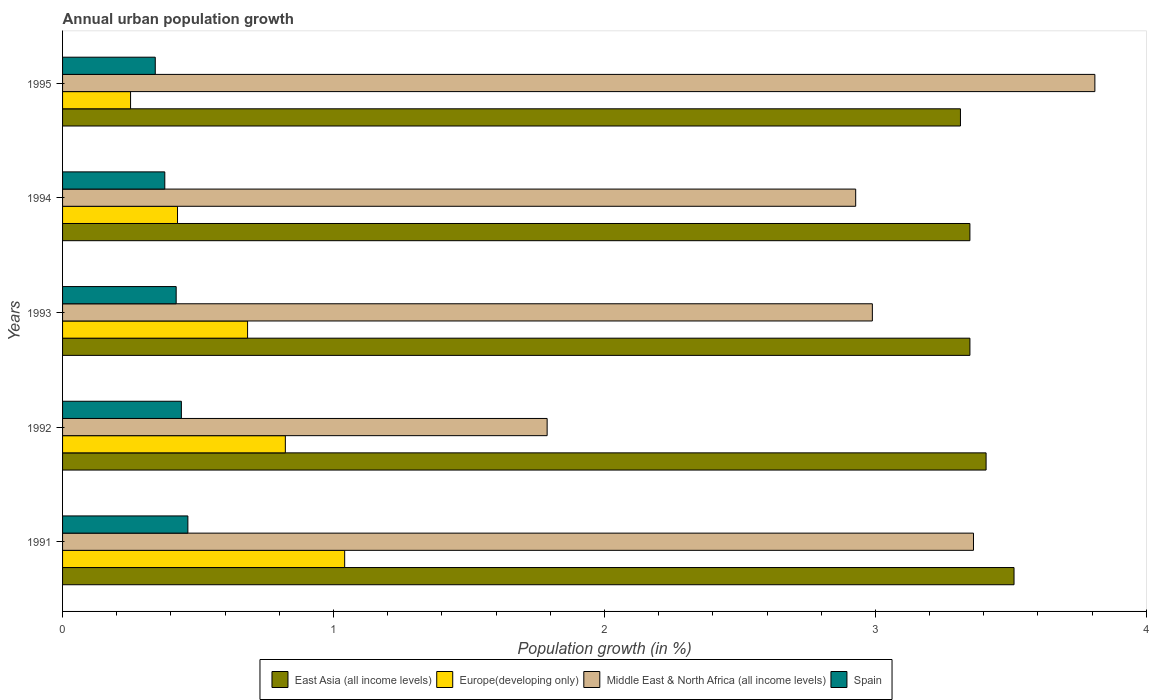How many different coloured bars are there?
Provide a succinct answer. 4. Are the number of bars per tick equal to the number of legend labels?
Provide a short and direct response. Yes. Are the number of bars on each tick of the Y-axis equal?
Make the answer very short. Yes. How many bars are there on the 1st tick from the top?
Give a very brief answer. 4. What is the label of the 1st group of bars from the top?
Give a very brief answer. 1995. In how many cases, is the number of bars for a given year not equal to the number of legend labels?
Keep it short and to the point. 0. What is the percentage of urban population growth in Europe(developing only) in 1995?
Keep it short and to the point. 0.25. Across all years, what is the maximum percentage of urban population growth in Spain?
Make the answer very short. 0.46. Across all years, what is the minimum percentage of urban population growth in Middle East & North Africa (all income levels)?
Make the answer very short. 1.79. What is the total percentage of urban population growth in Middle East & North Africa (all income levels) in the graph?
Keep it short and to the point. 14.88. What is the difference between the percentage of urban population growth in Europe(developing only) in 1993 and that in 1995?
Provide a short and direct response. 0.43. What is the difference between the percentage of urban population growth in Middle East & North Africa (all income levels) in 1993 and the percentage of urban population growth in East Asia (all income levels) in 1995?
Offer a terse response. -0.33. What is the average percentage of urban population growth in Spain per year?
Your response must be concise. 0.41. In the year 1991, what is the difference between the percentage of urban population growth in Spain and percentage of urban population growth in Europe(developing only)?
Make the answer very short. -0.58. In how many years, is the percentage of urban population growth in Spain greater than 2.6 %?
Provide a succinct answer. 0. What is the ratio of the percentage of urban population growth in Middle East & North Africa (all income levels) in 1993 to that in 1994?
Offer a very short reply. 1.02. Is the difference between the percentage of urban population growth in Spain in 1991 and 1994 greater than the difference between the percentage of urban population growth in Europe(developing only) in 1991 and 1994?
Offer a terse response. No. What is the difference between the highest and the second highest percentage of urban population growth in Spain?
Your response must be concise. 0.02. What is the difference between the highest and the lowest percentage of urban population growth in Europe(developing only)?
Give a very brief answer. 0.79. Is the sum of the percentage of urban population growth in Middle East & North Africa (all income levels) in 1994 and 1995 greater than the maximum percentage of urban population growth in Spain across all years?
Give a very brief answer. Yes. Is it the case that in every year, the sum of the percentage of urban population growth in Europe(developing only) and percentage of urban population growth in Middle East & North Africa (all income levels) is greater than the sum of percentage of urban population growth in East Asia (all income levels) and percentage of urban population growth in Spain?
Provide a succinct answer. Yes. What does the 1st bar from the bottom in 1992 represents?
Offer a terse response. East Asia (all income levels). Is it the case that in every year, the sum of the percentage of urban population growth in East Asia (all income levels) and percentage of urban population growth in Europe(developing only) is greater than the percentage of urban population growth in Middle East & North Africa (all income levels)?
Keep it short and to the point. No. Are all the bars in the graph horizontal?
Your answer should be very brief. Yes. How many years are there in the graph?
Provide a succinct answer. 5. What is the difference between two consecutive major ticks on the X-axis?
Ensure brevity in your answer.  1. Are the values on the major ticks of X-axis written in scientific E-notation?
Your response must be concise. No. Does the graph contain grids?
Your answer should be very brief. No. Where does the legend appear in the graph?
Your answer should be very brief. Bottom center. What is the title of the graph?
Your response must be concise. Annual urban population growth. Does "Panama" appear as one of the legend labels in the graph?
Your answer should be compact. No. What is the label or title of the X-axis?
Give a very brief answer. Population growth (in %). What is the label or title of the Y-axis?
Your response must be concise. Years. What is the Population growth (in %) of East Asia (all income levels) in 1991?
Your answer should be compact. 3.51. What is the Population growth (in %) in Europe(developing only) in 1991?
Your response must be concise. 1.04. What is the Population growth (in %) of Middle East & North Africa (all income levels) in 1991?
Your answer should be very brief. 3.36. What is the Population growth (in %) in Spain in 1991?
Keep it short and to the point. 0.46. What is the Population growth (in %) in East Asia (all income levels) in 1992?
Provide a short and direct response. 3.41. What is the Population growth (in %) in Europe(developing only) in 1992?
Offer a terse response. 0.82. What is the Population growth (in %) in Middle East & North Africa (all income levels) in 1992?
Provide a short and direct response. 1.79. What is the Population growth (in %) in Spain in 1992?
Make the answer very short. 0.44. What is the Population growth (in %) in East Asia (all income levels) in 1993?
Provide a succinct answer. 3.35. What is the Population growth (in %) in Europe(developing only) in 1993?
Give a very brief answer. 0.68. What is the Population growth (in %) of Middle East & North Africa (all income levels) in 1993?
Ensure brevity in your answer.  2.99. What is the Population growth (in %) in Spain in 1993?
Provide a short and direct response. 0.42. What is the Population growth (in %) of East Asia (all income levels) in 1994?
Offer a very short reply. 3.35. What is the Population growth (in %) in Europe(developing only) in 1994?
Offer a terse response. 0.42. What is the Population growth (in %) of Middle East & North Africa (all income levels) in 1994?
Ensure brevity in your answer.  2.93. What is the Population growth (in %) in Spain in 1994?
Your answer should be compact. 0.38. What is the Population growth (in %) of East Asia (all income levels) in 1995?
Your response must be concise. 3.31. What is the Population growth (in %) of Europe(developing only) in 1995?
Keep it short and to the point. 0.25. What is the Population growth (in %) in Middle East & North Africa (all income levels) in 1995?
Keep it short and to the point. 3.81. What is the Population growth (in %) of Spain in 1995?
Your answer should be very brief. 0.34. Across all years, what is the maximum Population growth (in %) in East Asia (all income levels)?
Give a very brief answer. 3.51. Across all years, what is the maximum Population growth (in %) in Europe(developing only)?
Provide a short and direct response. 1.04. Across all years, what is the maximum Population growth (in %) in Middle East & North Africa (all income levels)?
Provide a short and direct response. 3.81. Across all years, what is the maximum Population growth (in %) of Spain?
Provide a short and direct response. 0.46. Across all years, what is the minimum Population growth (in %) of East Asia (all income levels)?
Offer a very short reply. 3.31. Across all years, what is the minimum Population growth (in %) of Europe(developing only)?
Provide a short and direct response. 0.25. Across all years, what is the minimum Population growth (in %) in Middle East & North Africa (all income levels)?
Provide a short and direct response. 1.79. Across all years, what is the minimum Population growth (in %) of Spain?
Offer a very short reply. 0.34. What is the total Population growth (in %) of East Asia (all income levels) in the graph?
Provide a succinct answer. 16.93. What is the total Population growth (in %) of Europe(developing only) in the graph?
Make the answer very short. 3.22. What is the total Population growth (in %) of Middle East & North Africa (all income levels) in the graph?
Make the answer very short. 14.88. What is the total Population growth (in %) of Spain in the graph?
Make the answer very short. 2.04. What is the difference between the Population growth (in %) in East Asia (all income levels) in 1991 and that in 1992?
Provide a short and direct response. 0.1. What is the difference between the Population growth (in %) of Europe(developing only) in 1991 and that in 1992?
Your response must be concise. 0.22. What is the difference between the Population growth (in %) in Middle East & North Africa (all income levels) in 1991 and that in 1992?
Your response must be concise. 1.57. What is the difference between the Population growth (in %) in Spain in 1991 and that in 1992?
Provide a short and direct response. 0.02. What is the difference between the Population growth (in %) of East Asia (all income levels) in 1991 and that in 1993?
Your response must be concise. 0.16. What is the difference between the Population growth (in %) in Europe(developing only) in 1991 and that in 1993?
Keep it short and to the point. 0.36. What is the difference between the Population growth (in %) in Middle East & North Africa (all income levels) in 1991 and that in 1993?
Your response must be concise. 0.37. What is the difference between the Population growth (in %) in Spain in 1991 and that in 1993?
Your answer should be very brief. 0.04. What is the difference between the Population growth (in %) in East Asia (all income levels) in 1991 and that in 1994?
Ensure brevity in your answer.  0.16. What is the difference between the Population growth (in %) in Europe(developing only) in 1991 and that in 1994?
Provide a succinct answer. 0.62. What is the difference between the Population growth (in %) in Middle East & North Africa (all income levels) in 1991 and that in 1994?
Your response must be concise. 0.43. What is the difference between the Population growth (in %) of Spain in 1991 and that in 1994?
Offer a terse response. 0.09. What is the difference between the Population growth (in %) in East Asia (all income levels) in 1991 and that in 1995?
Provide a short and direct response. 0.2. What is the difference between the Population growth (in %) in Europe(developing only) in 1991 and that in 1995?
Provide a short and direct response. 0.79. What is the difference between the Population growth (in %) in Middle East & North Africa (all income levels) in 1991 and that in 1995?
Offer a terse response. -0.45. What is the difference between the Population growth (in %) in Spain in 1991 and that in 1995?
Your answer should be compact. 0.12. What is the difference between the Population growth (in %) of East Asia (all income levels) in 1992 and that in 1993?
Offer a very short reply. 0.06. What is the difference between the Population growth (in %) in Europe(developing only) in 1992 and that in 1993?
Keep it short and to the point. 0.14. What is the difference between the Population growth (in %) of Middle East & North Africa (all income levels) in 1992 and that in 1993?
Your response must be concise. -1.2. What is the difference between the Population growth (in %) of Spain in 1992 and that in 1993?
Keep it short and to the point. 0.02. What is the difference between the Population growth (in %) in East Asia (all income levels) in 1992 and that in 1994?
Your answer should be very brief. 0.06. What is the difference between the Population growth (in %) in Europe(developing only) in 1992 and that in 1994?
Give a very brief answer. 0.4. What is the difference between the Population growth (in %) in Middle East & North Africa (all income levels) in 1992 and that in 1994?
Give a very brief answer. -1.14. What is the difference between the Population growth (in %) of Spain in 1992 and that in 1994?
Offer a terse response. 0.06. What is the difference between the Population growth (in %) in East Asia (all income levels) in 1992 and that in 1995?
Your answer should be very brief. 0.09. What is the difference between the Population growth (in %) in Europe(developing only) in 1992 and that in 1995?
Keep it short and to the point. 0.57. What is the difference between the Population growth (in %) in Middle East & North Africa (all income levels) in 1992 and that in 1995?
Offer a very short reply. -2.02. What is the difference between the Population growth (in %) in Spain in 1992 and that in 1995?
Provide a short and direct response. 0.1. What is the difference between the Population growth (in %) in Europe(developing only) in 1993 and that in 1994?
Make the answer very short. 0.26. What is the difference between the Population growth (in %) in Middle East & North Africa (all income levels) in 1993 and that in 1994?
Offer a very short reply. 0.06. What is the difference between the Population growth (in %) in Spain in 1993 and that in 1994?
Ensure brevity in your answer.  0.04. What is the difference between the Population growth (in %) in East Asia (all income levels) in 1993 and that in 1995?
Offer a terse response. 0.04. What is the difference between the Population growth (in %) of Europe(developing only) in 1993 and that in 1995?
Offer a very short reply. 0.43. What is the difference between the Population growth (in %) in Middle East & North Africa (all income levels) in 1993 and that in 1995?
Provide a succinct answer. -0.82. What is the difference between the Population growth (in %) of Spain in 1993 and that in 1995?
Ensure brevity in your answer.  0.08. What is the difference between the Population growth (in %) of East Asia (all income levels) in 1994 and that in 1995?
Give a very brief answer. 0.03. What is the difference between the Population growth (in %) of Europe(developing only) in 1994 and that in 1995?
Your answer should be compact. 0.17. What is the difference between the Population growth (in %) in Middle East & North Africa (all income levels) in 1994 and that in 1995?
Keep it short and to the point. -0.88. What is the difference between the Population growth (in %) in Spain in 1994 and that in 1995?
Your answer should be compact. 0.04. What is the difference between the Population growth (in %) in East Asia (all income levels) in 1991 and the Population growth (in %) in Europe(developing only) in 1992?
Offer a very short reply. 2.69. What is the difference between the Population growth (in %) of East Asia (all income levels) in 1991 and the Population growth (in %) of Middle East & North Africa (all income levels) in 1992?
Keep it short and to the point. 1.72. What is the difference between the Population growth (in %) in East Asia (all income levels) in 1991 and the Population growth (in %) in Spain in 1992?
Provide a short and direct response. 3.07. What is the difference between the Population growth (in %) of Europe(developing only) in 1991 and the Population growth (in %) of Middle East & North Africa (all income levels) in 1992?
Provide a succinct answer. -0.75. What is the difference between the Population growth (in %) in Europe(developing only) in 1991 and the Population growth (in %) in Spain in 1992?
Your answer should be very brief. 0.6. What is the difference between the Population growth (in %) in Middle East & North Africa (all income levels) in 1991 and the Population growth (in %) in Spain in 1992?
Your answer should be compact. 2.92. What is the difference between the Population growth (in %) in East Asia (all income levels) in 1991 and the Population growth (in %) in Europe(developing only) in 1993?
Offer a terse response. 2.83. What is the difference between the Population growth (in %) of East Asia (all income levels) in 1991 and the Population growth (in %) of Middle East & North Africa (all income levels) in 1993?
Your response must be concise. 0.52. What is the difference between the Population growth (in %) in East Asia (all income levels) in 1991 and the Population growth (in %) in Spain in 1993?
Give a very brief answer. 3.09. What is the difference between the Population growth (in %) in Europe(developing only) in 1991 and the Population growth (in %) in Middle East & North Africa (all income levels) in 1993?
Your response must be concise. -1.95. What is the difference between the Population growth (in %) of Europe(developing only) in 1991 and the Population growth (in %) of Spain in 1993?
Ensure brevity in your answer.  0.62. What is the difference between the Population growth (in %) of Middle East & North Africa (all income levels) in 1991 and the Population growth (in %) of Spain in 1993?
Offer a terse response. 2.94. What is the difference between the Population growth (in %) of East Asia (all income levels) in 1991 and the Population growth (in %) of Europe(developing only) in 1994?
Offer a very short reply. 3.09. What is the difference between the Population growth (in %) in East Asia (all income levels) in 1991 and the Population growth (in %) in Middle East & North Africa (all income levels) in 1994?
Give a very brief answer. 0.58. What is the difference between the Population growth (in %) in East Asia (all income levels) in 1991 and the Population growth (in %) in Spain in 1994?
Give a very brief answer. 3.13. What is the difference between the Population growth (in %) in Europe(developing only) in 1991 and the Population growth (in %) in Middle East & North Africa (all income levels) in 1994?
Ensure brevity in your answer.  -1.89. What is the difference between the Population growth (in %) in Europe(developing only) in 1991 and the Population growth (in %) in Spain in 1994?
Make the answer very short. 0.66. What is the difference between the Population growth (in %) in Middle East & North Africa (all income levels) in 1991 and the Population growth (in %) in Spain in 1994?
Your answer should be compact. 2.98. What is the difference between the Population growth (in %) of East Asia (all income levels) in 1991 and the Population growth (in %) of Europe(developing only) in 1995?
Your response must be concise. 3.26. What is the difference between the Population growth (in %) of East Asia (all income levels) in 1991 and the Population growth (in %) of Middle East & North Africa (all income levels) in 1995?
Your response must be concise. -0.3. What is the difference between the Population growth (in %) in East Asia (all income levels) in 1991 and the Population growth (in %) in Spain in 1995?
Your answer should be very brief. 3.17. What is the difference between the Population growth (in %) in Europe(developing only) in 1991 and the Population growth (in %) in Middle East & North Africa (all income levels) in 1995?
Provide a short and direct response. -2.77. What is the difference between the Population growth (in %) of Europe(developing only) in 1991 and the Population growth (in %) of Spain in 1995?
Ensure brevity in your answer.  0.7. What is the difference between the Population growth (in %) in Middle East & North Africa (all income levels) in 1991 and the Population growth (in %) in Spain in 1995?
Your response must be concise. 3.02. What is the difference between the Population growth (in %) of East Asia (all income levels) in 1992 and the Population growth (in %) of Europe(developing only) in 1993?
Ensure brevity in your answer.  2.73. What is the difference between the Population growth (in %) of East Asia (all income levels) in 1992 and the Population growth (in %) of Middle East & North Africa (all income levels) in 1993?
Provide a short and direct response. 0.42. What is the difference between the Population growth (in %) in East Asia (all income levels) in 1992 and the Population growth (in %) in Spain in 1993?
Offer a very short reply. 2.99. What is the difference between the Population growth (in %) of Europe(developing only) in 1992 and the Population growth (in %) of Middle East & North Africa (all income levels) in 1993?
Your answer should be very brief. -2.17. What is the difference between the Population growth (in %) of Europe(developing only) in 1992 and the Population growth (in %) of Spain in 1993?
Your answer should be compact. 0.4. What is the difference between the Population growth (in %) in Middle East & North Africa (all income levels) in 1992 and the Population growth (in %) in Spain in 1993?
Give a very brief answer. 1.37. What is the difference between the Population growth (in %) of East Asia (all income levels) in 1992 and the Population growth (in %) of Europe(developing only) in 1994?
Offer a terse response. 2.98. What is the difference between the Population growth (in %) in East Asia (all income levels) in 1992 and the Population growth (in %) in Middle East & North Africa (all income levels) in 1994?
Keep it short and to the point. 0.48. What is the difference between the Population growth (in %) of East Asia (all income levels) in 1992 and the Population growth (in %) of Spain in 1994?
Your answer should be very brief. 3.03. What is the difference between the Population growth (in %) in Europe(developing only) in 1992 and the Population growth (in %) in Middle East & North Africa (all income levels) in 1994?
Make the answer very short. -2.1. What is the difference between the Population growth (in %) of Europe(developing only) in 1992 and the Population growth (in %) of Spain in 1994?
Make the answer very short. 0.44. What is the difference between the Population growth (in %) in Middle East & North Africa (all income levels) in 1992 and the Population growth (in %) in Spain in 1994?
Make the answer very short. 1.41. What is the difference between the Population growth (in %) of East Asia (all income levels) in 1992 and the Population growth (in %) of Europe(developing only) in 1995?
Your answer should be compact. 3.16. What is the difference between the Population growth (in %) in East Asia (all income levels) in 1992 and the Population growth (in %) in Middle East & North Africa (all income levels) in 1995?
Give a very brief answer. -0.4. What is the difference between the Population growth (in %) of East Asia (all income levels) in 1992 and the Population growth (in %) of Spain in 1995?
Ensure brevity in your answer.  3.07. What is the difference between the Population growth (in %) in Europe(developing only) in 1992 and the Population growth (in %) in Middle East & North Africa (all income levels) in 1995?
Offer a terse response. -2.99. What is the difference between the Population growth (in %) in Europe(developing only) in 1992 and the Population growth (in %) in Spain in 1995?
Provide a succinct answer. 0.48. What is the difference between the Population growth (in %) in Middle East & North Africa (all income levels) in 1992 and the Population growth (in %) in Spain in 1995?
Your answer should be very brief. 1.45. What is the difference between the Population growth (in %) in East Asia (all income levels) in 1993 and the Population growth (in %) in Europe(developing only) in 1994?
Give a very brief answer. 2.92. What is the difference between the Population growth (in %) of East Asia (all income levels) in 1993 and the Population growth (in %) of Middle East & North Africa (all income levels) in 1994?
Make the answer very short. 0.42. What is the difference between the Population growth (in %) of East Asia (all income levels) in 1993 and the Population growth (in %) of Spain in 1994?
Keep it short and to the point. 2.97. What is the difference between the Population growth (in %) of Europe(developing only) in 1993 and the Population growth (in %) of Middle East & North Africa (all income levels) in 1994?
Keep it short and to the point. -2.24. What is the difference between the Population growth (in %) of Europe(developing only) in 1993 and the Population growth (in %) of Spain in 1994?
Ensure brevity in your answer.  0.31. What is the difference between the Population growth (in %) of Middle East & North Africa (all income levels) in 1993 and the Population growth (in %) of Spain in 1994?
Give a very brief answer. 2.61. What is the difference between the Population growth (in %) in East Asia (all income levels) in 1993 and the Population growth (in %) in Europe(developing only) in 1995?
Your response must be concise. 3.1. What is the difference between the Population growth (in %) of East Asia (all income levels) in 1993 and the Population growth (in %) of Middle East & North Africa (all income levels) in 1995?
Give a very brief answer. -0.46. What is the difference between the Population growth (in %) of East Asia (all income levels) in 1993 and the Population growth (in %) of Spain in 1995?
Give a very brief answer. 3.01. What is the difference between the Population growth (in %) of Europe(developing only) in 1993 and the Population growth (in %) of Middle East & North Africa (all income levels) in 1995?
Offer a terse response. -3.13. What is the difference between the Population growth (in %) of Europe(developing only) in 1993 and the Population growth (in %) of Spain in 1995?
Your response must be concise. 0.34. What is the difference between the Population growth (in %) in Middle East & North Africa (all income levels) in 1993 and the Population growth (in %) in Spain in 1995?
Make the answer very short. 2.65. What is the difference between the Population growth (in %) of East Asia (all income levels) in 1994 and the Population growth (in %) of Europe(developing only) in 1995?
Offer a terse response. 3.1. What is the difference between the Population growth (in %) of East Asia (all income levels) in 1994 and the Population growth (in %) of Middle East & North Africa (all income levels) in 1995?
Ensure brevity in your answer.  -0.46. What is the difference between the Population growth (in %) of East Asia (all income levels) in 1994 and the Population growth (in %) of Spain in 1995?
Make the answer very short. 3.01. What is the difference between the Population growth (in %) of Europe(developing only) in 1994 and the Population growth (in %) of Middle East & North Africa (all income levels) in 1995?
Your answer should be compact. -3.39. What is the difference between the Population growth (in %) of Europe(developing only) in 1994 and the Population growth (in %) of Spain in 1995?
Ensure brevity in your answer.  0.08. What is the difference between the Population growth (in %) of Middle East & North Africa (all income levels) in 1994 and the Population growth (in %) of Spain in 1995?
Offer a terse response. 2.58. What is the average Population growth (in %) in East Asia (all income levels) per year?
Give a very brief answer. 3.39. What is the average Population growth (in %) of Europe(developing only) per year?
Your answer should be very brief. 0.64. What is the average Population growth (in %) of Middle East & North Africa (all income levels) per year?
Offer a very short reply. 2.98. What is the average Population growth (in %) in Spain per year?
Offer a terse response. 0.41. In the year 1991, what is the difference between the Population growth (in %) of East Asia (all income levels) and Population growth (in %) of Europe(developing only)?
Offer a very short reply. 2.47. In the year 1991, what is the difference between the Population growth (in %) of East Asia (all income levels) and Population growth (in %) of Middle East & North Africa (all income levels)?
Offer a very short reply. 0.15. In the year 1991, what is the difference between the Population growth (in %) in East Asia (all income levels) and Population growth (in %) in Spain?
Offer a terse response. 3.05. In the year 1991, what is the difference between the Population growth (in %) in Europe(developing only) and Population growth (in %) in Middle East & North Africa (all income levels)?
Give a very brief answer. -2.32. In the year 1991, what is the difference between the Population growth (in %) in Europe(developing only) and Population growth (in %) in Spain?
Provide a short and direct response. 0.58. In the year 1991, what is the difference between the Population growth (in %) in Middle East & North Africa (all income levels) and Population growth (in %) in Spain?
Give a very brief answer. 2.9. In the year 1992, what is the difference between the Population growth (in %) of East Asia (all income levels) and Population growth (in %) of Europe(developing only)?
Keep it short and to the point. 2.59. In the year 1992, what is the difference between the Population growth (in %) in East Asia (all income levels) and Population growth (in %) in Middle East & North Africa (all income levels)?
Provide a succinct answer. 1.62. In the year 1992, what is the difference between the Population growth (in %) in East Asia (all income levels) and Population growth (in %) in Spain?
Offer a terse response. 2.97. In the year 1992, what is the difference between the Population growth (in %) in Europe(developing only) and Population growth (in %) in Middle East & North Africa (all income levels)?
Provide a short and direct response. -0.97. In the year 1992, what is the difference between the Population growth (in %) in Europe(developing only) and Population growth (in %) in Spain?
Offer a terse response. 0.38. In the year 1992, what is the difference between the Population growth (in %) of Middle East & North Africa (all income levels) and Population growth (in %) of Spain?
Give a very brief answer. 1.35. In the year 1993, what is the difference between the Population growth (in %) of East Asia (all income levels) and Population growth (in %) of Europe(developing only)?
Provide a short and direct response. 2.67. In the year 1993, what is the difference between the Population growth (in %) in East Asia (all income levels) and Population growth (in %) in Middle East & North Africa (all income levels)?
Your answer should be compact. 0.36. In the year 1993, what is the difference between the Population growth (in %) in East Asia (all income levels) and Population growth (in %) in Spain?
Give a very brief answer. 2.93. In the year 1993, what is the difference between the Population growth (in %) in Europe(developing only) and Population growth (in %) in Middle East & North Africa (all income levels)?
Offer a terse response. -2.31. In the year 1993, what is the difference between the Population growth (in %) in Europe(developing only) and Population growth (in %) in Spain?
Your answer should be compact. 0.26. In the year 1993, what is the difference between the Population growth (in %) of Middle East & North Africa (all income levels) and Population growth (in %) of Spain?
Offer a very short reply. 2.57. In the year 1994, what is the difference between the Population growth (in %) of East Asia (all income levels) and Population growth (in %) of Europe(developing only)?
Your answer should be very brief. 2.92. In the year 1994, what is the difference between the Population growth (in %) of East Asia (all income levels) and Population growth (in %) of Middle East & North Africa (all income levels)?
Make the answer very short. 0.42. In the year 1994, what is the difference between the Population growth (in %) in East Asia (all income levels) and Population growth (in %) in Spain?
Give a very brief answer. 2.97. In the year 1994, what is the difference between the Population growth (in %) of Europe(developing only) and Population growth (in %) of Middle East & North Africa (all income levels)?
Offer a very short reply. -2.5. In the year 1994, what is the difference between the Population growth (in %) in Europe(developing only) and Population growth (in %) in Spain?
Provide a short and direct response. 0.05. In the year 1994, what is the difference between the Population growth (in %) of Middle East & North Africa (all income levels) and Population growth (in %) of Spain?
Ensure brevity in your answer.  2.55. In the year 1995, what is the difference between the Population growth (in %) of East Asia (all income levels) and Population growth (in %) of Europe(developing only)?
Provide a succinct answer. 3.06. In the year 1995, what is the difference between the Population growth (in %) in East Asia (all income levels) and Population growth (in %) in Middle East & North Africa (all income levels)?
Provide a succinct answer. -0.5. In the year 1995, what is the difference between the Population growth (in %) in East Asia (all income levels) and Population growth (in %) in Spain?
Provide a short and direct response. 2.97. In the year 1995, what is the difference between the Population growth (in %) in Europe(developing only) and Population growth (in %) in Middle East & North Africa (all income levels)?
Provide a succinct answer. -3.56. In the year 1995, what is the difference between the Population growth (in %) of Europe(developing only) and Population growth (in %) of Spain?
Your answer should be compact. -0.09. In the year 1995, what is the difference between the Population growth (in %) of Middle East & North Africa (all income levels) and Population growth (in %) of Spain?
Offer a terse response. 3.47. What is the ratio of the Population growth (in %) in East Asia (all income levels) in 1991 to that in 1992?
Your answer should be very brief. 1.03. What is the ratio of the Population growth (in %) in Europe(developing only) in 1991 to that in 1992?
Give a very brief answer. 1.27. What is the ratio of the Population growth (in %) of Middle East & North Africa (all income levels) in 1991 to that in 1992?
Ensure brevity in your answer.  1.88. What is the ratio of the Population growth (in %) of Spain in 1991 to that in 1992?
Offer a very short reply. 1.05. What is the ratio of the Population growth (in %) in East Asia (all income levels) in 1991 to that in 1993?
Your response must be concise. 1.05. What is the ratio of the Population growth (in %) of Europe(developing only) in 1991 to that in 1993?
Make the answer very short. 1.52. What is the ratio of the Population growth (in %) of Middle East & North Africa (all income levels) in 1991 to that in 1993?
Your response must be concise. 1.12. What is the ratio of the Population growth (in %) of Spain in 1991 to that in 1993?
Your answer should be compact. 1.1. What is the ratio of the Population growth (in %) of East Asia (all income levels) in 1991 to that in 1994?
Your answer should be very brief. 1.05. What is the ratio of the Population growth (in %) in Europe(developing only) in 1991 to that in 1994?
Keep it short and to the point. 2.45. What is the ratio of the Population growth (in %) of Middle East & North Africa (all income levels) in 1991 to that in 1994?
Your answer should be compact. 1.15. What is the ratio of the Population growth (in %) in Spain in 1991 to that in 1994?
Keep it short and to the point. 1.23. What is the ratio of the Population growth (in %) of East Asia (all income levels) in 1991 to that in 1995?
Ensure brevity in your answer.  1.06. What is the ratio of the Population growth (in %) in Europe(developing only) in 1991 to that in 1995?
Offer a very short reply. 4.15. What is the ratio of the Population growth (in %) of Middle East & North Africa (all income levels) in 1991 to that in 1995?
Keep it short and to the point. 0.88. What is the ratio of the Population growth (in %) of Spain in 1991 to that in 1995?
Provide a short and direct response. 1.35. What is the ratio of the Population growth (in %) of East Asia (all income levels) in 1992 to that in 1993?
Provide a short and direct response. 1.02. What is the ratio of the Population growth (in %) of Europe(developing only) in 1992 to that in 1993?
Keep it short and to the point. 1.2. What is the ratio of the Population growth (in %) of Middle East & North Africa (all income levels) in 1992 to that in 1993?
Make the answer very short. 0.6. What is the ratio of the Population growth (in %) of Spain in 1992 to that in 1993?
Give a very brief answer. 1.05. What is the ratio of the Population growth (in %) of East Asia (all income levels) in 1992 to that in 1994?
Keep it short and to the point. 1.02. What is the ratio of the Population growth (in %) of Europe(developing only) in 1992 to that in 1994?
Your answer should be compact. 1.94. What is the ratio of the Population growth (in %) in Middle East & North Africa (all income levels) in 1992 to that in 1994?
Provide a short and direct response. 0.61. What is the ratio of the Population growth (in %) of Spain in 1992 to that in 1994?
Provide a short and direct response. 1.16. What is the ratio of the Population growth (in %) of East Asia (all income levels) in 1992 to that in 1995?
Your answer should be very brief. 1.03. What is the ratio of the Population growth (in %) in Europe(developing only) in 1992 to that in 1995?
Make the answer very short. 3.28. What is the ratio of the Population growth (in %) in Middle East & North Africa (all income levels) in 1992 to that in 1995?
Offer a terse response. 0.47. What is the ratio of the Population growth (in %) in Spain in 1992 to that in 1995?
Provide a short and direct response. 1.28. What is the ratio of the Population growth (in %) in East Asia (all income levels) in 1993 to that in 1994?
Keep it short and to the point. 1. What is the ratio of the Population growth (in %) in Europe(developing only) in 1993 to that in 1994?
Offer a terse response. 1.61. What is the ratio of the Population growth (in %) in Spain in 1993 to that in 1994?
Your response must be concise. 1.11. What is the ratio of the Population growth (in %) of East Asia (all income levels) in 1993 to that in 1995?
Your answer should be very brief. 1.01. What is the ratio of the Population growth (in %) in Europe(developing only) in 1993 to that in 1995?
Provide a short and direct response. 2.72. What is the ratio of the Population growth (in %) of Middle East & North Africa (all income levels) in 1993 to that in 1995?
Ensure brevity in your answer.  0.78. What is the ratio of the Population growth (in %) in Spain in 1993 to that in 1995?
Provide a short and direct response. 1.23. What is the ratio of the Population growth (in %) in East Asia (all income levels) in 1994 to that in 1995?
Your answer should be compact. 1.01. What is the ratio of the Population growth (in %) of Europe(developing only) in 1994 to that in 1995?
Provide a short and direct response. 1.69. What is the ratio of the Population growth (in %) of Middle East & North Africa (all income levels) in 1994 to that in 1995?
Ensure brevity in your answer.  0.77. What is the ratio of the Population growth (in %) of Spain in 1994 to that in 1995?
Give a very brief answer. 1.1. What is the difference between the highest and the second highest Population growth (in %) in East Asia (all income levels)?
Make the answer very short. 0.1. What is the difference between the highest and the second highest Population growth (in %) of Europe(developing only)?
Offer a terse response. 0.22. What is the difference between the highest and the second highest Population growth (in %) of Middle East & North Africa (all income levels)?
Your answer should be compact. 0.45. What is the difference between the highest and the second highest Population growth (in %) in Spain?
Make the answer very short. 0.02. What is the difference between the highest and the lowest Population growth (in %) of East Asia (all income levels)?
Your response must be concise. 0.2. What is the difference between the highest and the lowest Population growth (in %) of Europe(developing only)?
Give a very brief answer. 0.79. What is the difference between the highest and the lowest Population growth (in %) of Middle East & North Africa (all income levels)?
Ensure brevity in your answer.  2.02. What is the difference between the highest and the lowest Population growth (in %) of Spain?
Give a very brief answer. 0.12. 